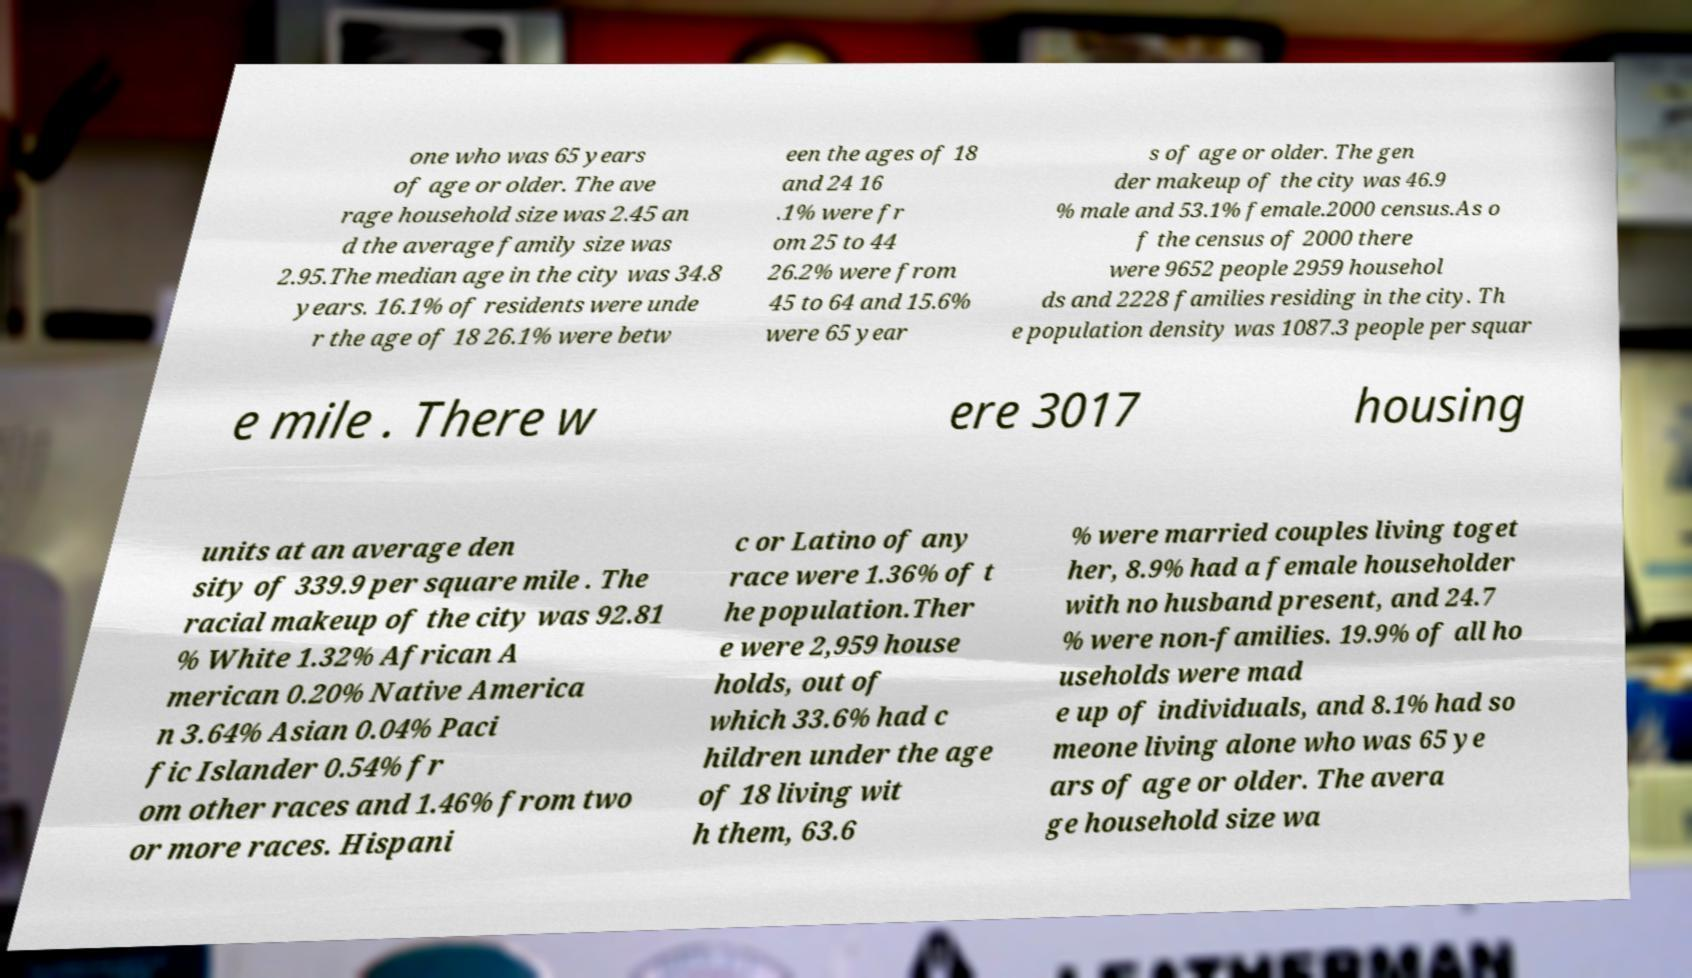Please identify and transcribe the text found in this image. one who was 65 years of age or older. The ave rage household size was 2.45 an d the average family size was 2.95.The median age in the city was 34.8 years. 16.1% of residents were unde r the age of 18 26.1% were betw een the ages of 18 and 24 16 .1% were fr om 25 to 44 26.2% were from 45 to 64 and 15.6% were 65 year s of age or older. The gen der makeup of the city was 46.9 % male and 53.1% female.2000 census.As o f the census of 2000 there were 9652 people 2959 househol ds and 2228 families residing in the city. Th e population density was 1087.3 people per squar e mile . There w ere 3017 housing units at an average den sity of 339.9 per square mile . The racial makeup of the city was 92.81 % White 1.32% African A merican 0.20% Native America n 3.64% Asian 0.04% Paci fic Islander 0.54% fr om other races and 1.46% from two or more races. Hispani c or Latino of any race were 1.36% of t he population.Ther e were 2,959 house holds, out of which 33.6% had c hildren under the age of 18 living wit h them, 63.6 % were married couples living toget her, 8.9% had a female householder with no husband present, and 24.7 % were non-families. 19.9% of all ho useholds were mad e up of individuals, and 8.1% had so meone living alone who was 65 ye ars of age or older. The avera ge household size wa 